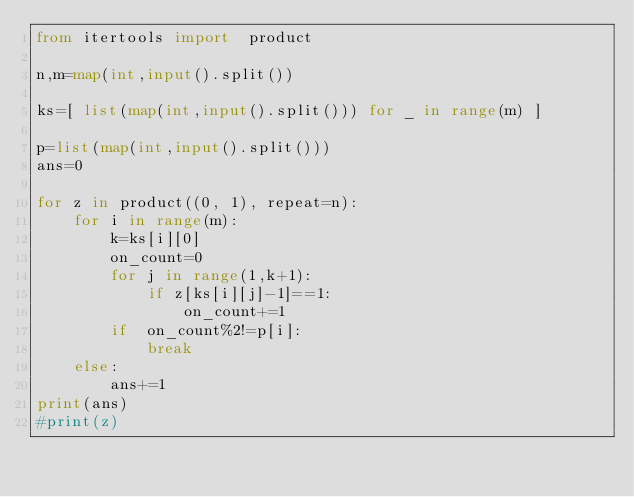<code> <loc_0><loc_0><loc_500><loc_500><_Python_>from itertools import  product

n,m=map(int,input().split())

ks=[ list(map(int,input().split())) for _ in range(m) ]

p=list(map(int,input().split()))
ans=0

for z in product((0, 1), repeat=n):
    for i in range(m):    
        k=ks[i][0]
        on_count=0
        for j in range(1,k+1):
            if z[ks[i][j]-1]==1:
                on_count+=1
        if  on_count%2!=p[i]:
            break
    else:
        ans+=1
print(ans)   
#print(z)</code> 